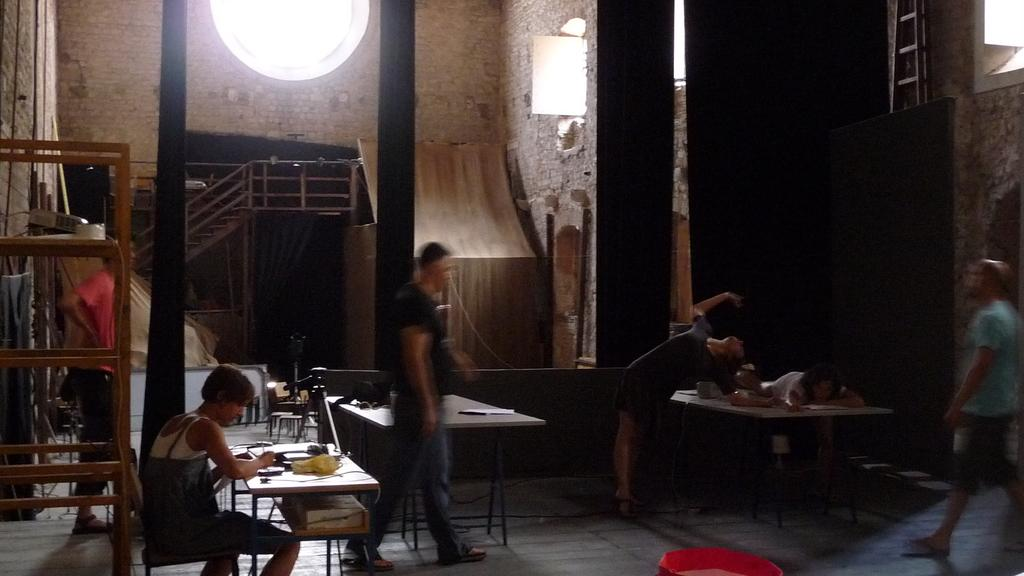Who or what is present in the image? There are people in the image. What objects are visible in the image? There are tables in the image. What can be found on the tables? There are things on the tables. What can be seen in the background of the image? There is a wall, stairs, and a big hole in the background of the image. How many chickens are on the tables in the image? There are no chickens present in the image. What type of notebook is being used by the people in the image? There is no notebook visible in the image. 